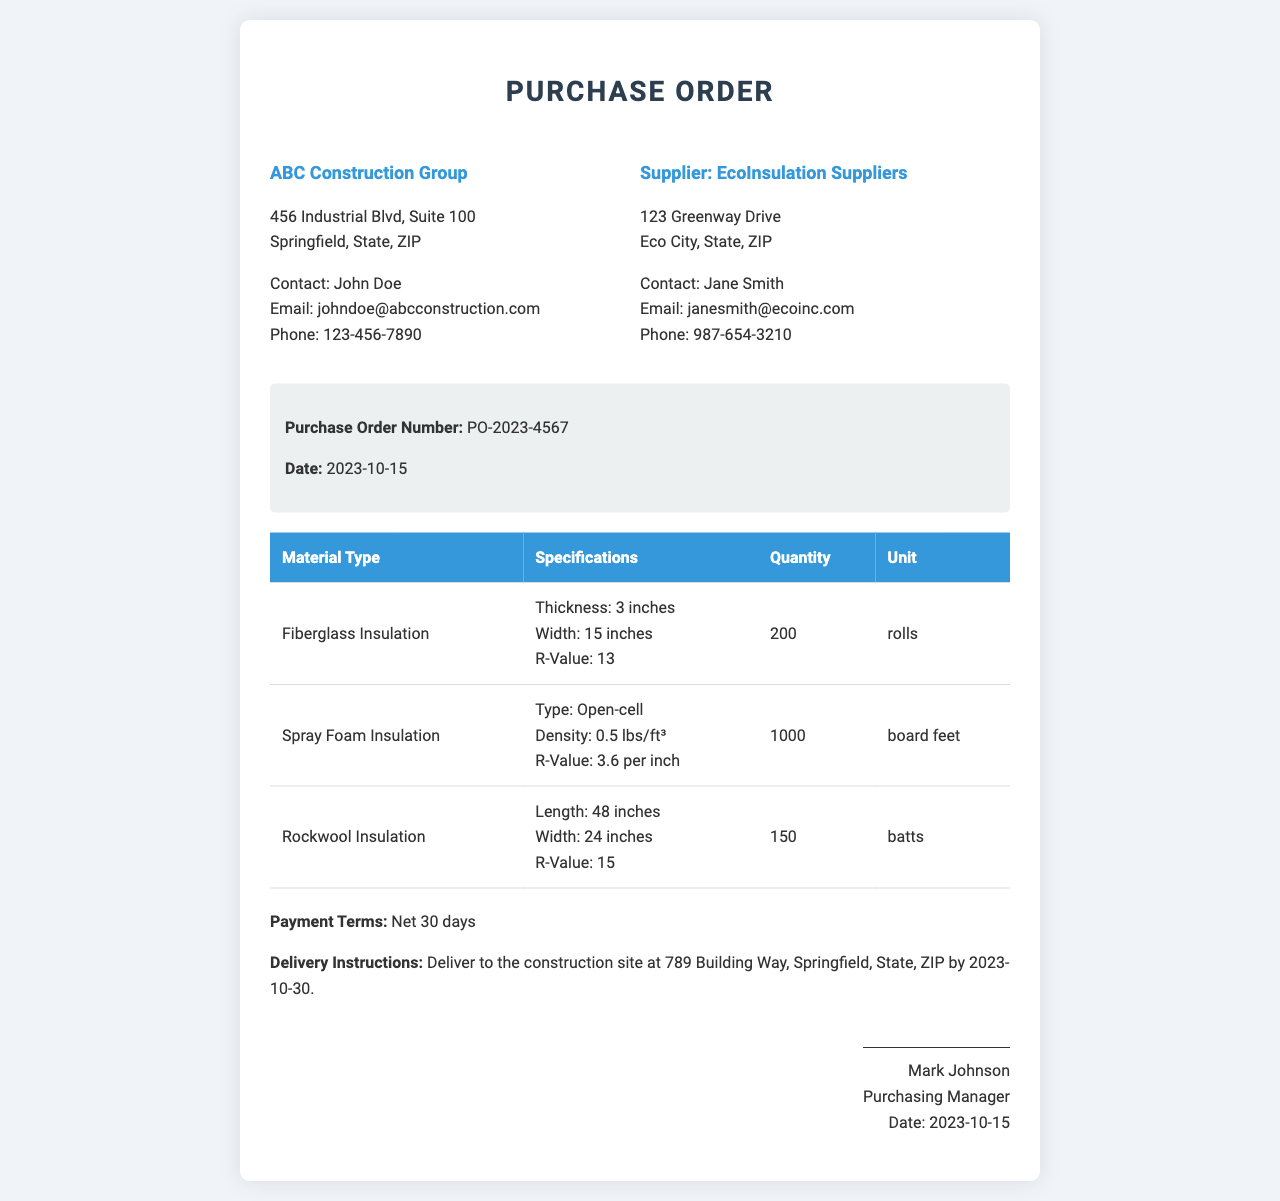What is the Purchase Order Number? The Purchase Order Number is listed prominently in the order details section of the document.
Answer: PO-2023-4567 Who is the contact person at EcoInsulation Suppliers? The contact person is mentioned under the supplier information section.
Answer: Jane Smith What is the quantity of Rockwool Insulation ordered? The quantity can be found in the table of materials under Rockwool Insulation.
Answer: 150 What are the delivery instructions? The delivery instructions detail where and by when the materials should be delivered.
Answer: Deliver to the construction site at 789 Building Way, Springfield, State, ZIP by 2023-10-30 What is the R-Value of Fiberglass Insulation? The R-Value is specified in the table for Fiberglass Insulation.
Answer: 13 What type of insulation is specified as open-cell? The type of insulation is outlined under its specifications in the table.
Answer: Spray Foam Insulation What is the payment term mentioned in the document? The payment term is noted in the order details section.
Answer: Net 30 days What is the date of the Purchase Order? The date is provided in the order details section of the document.
Answer: 2023-10-15 